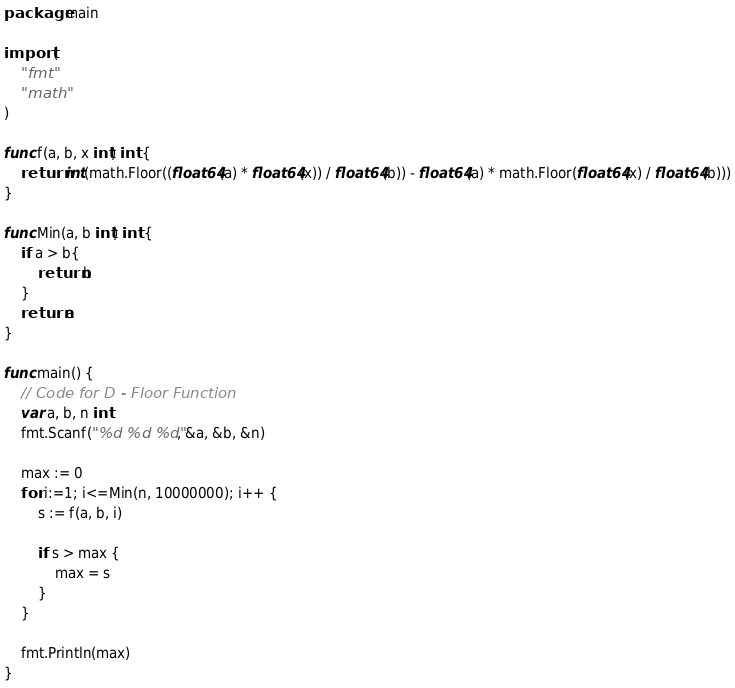<code> <loc_0><loc_0><loc_500><loc_500><_Go_>package main

import (
	"fmt"
	"math"
)

func f(a, b, x int) int {
	return int(math.Floor((float64(a) * float64(x)) / float64(b)) - float64(a) * math.Floor(float64(x) / float64(b)))
}

func Min(a, b int) int {
	if a > b{
		return b
	}
	return a
}

func main() {
	// Code for D - Floor Function
	var a, b, n int
	fmt.Scanf("%d %d %d", &a, &b, &n)

	max := 0
	for i:=1; i<=Min(n, 10000000); i++ {
		s := f(a, b, i)

		if s > max {
			max = s
		}
	}

	fmt.Println(max)
}</code> 